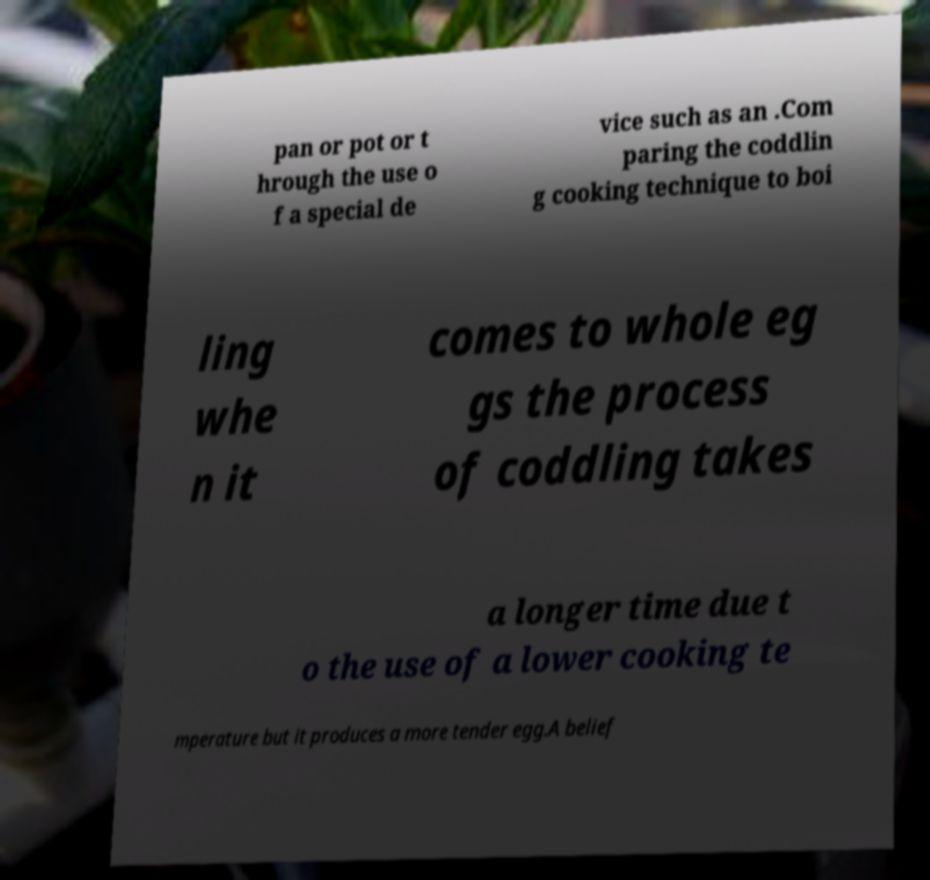Can you read and provide the text displayed in the image?This photo seems to have some interesting text. Can you extract and type it out for me? pan or pot or t hrough the use o f a special de vice such as an .Com paring the coddlin g cooking technique to boi ling whe n it comes to whole eg gs the process of coddling takes a longer time due t o the use of a lower cooking te mperature but it produces a more tender egg.A belief 